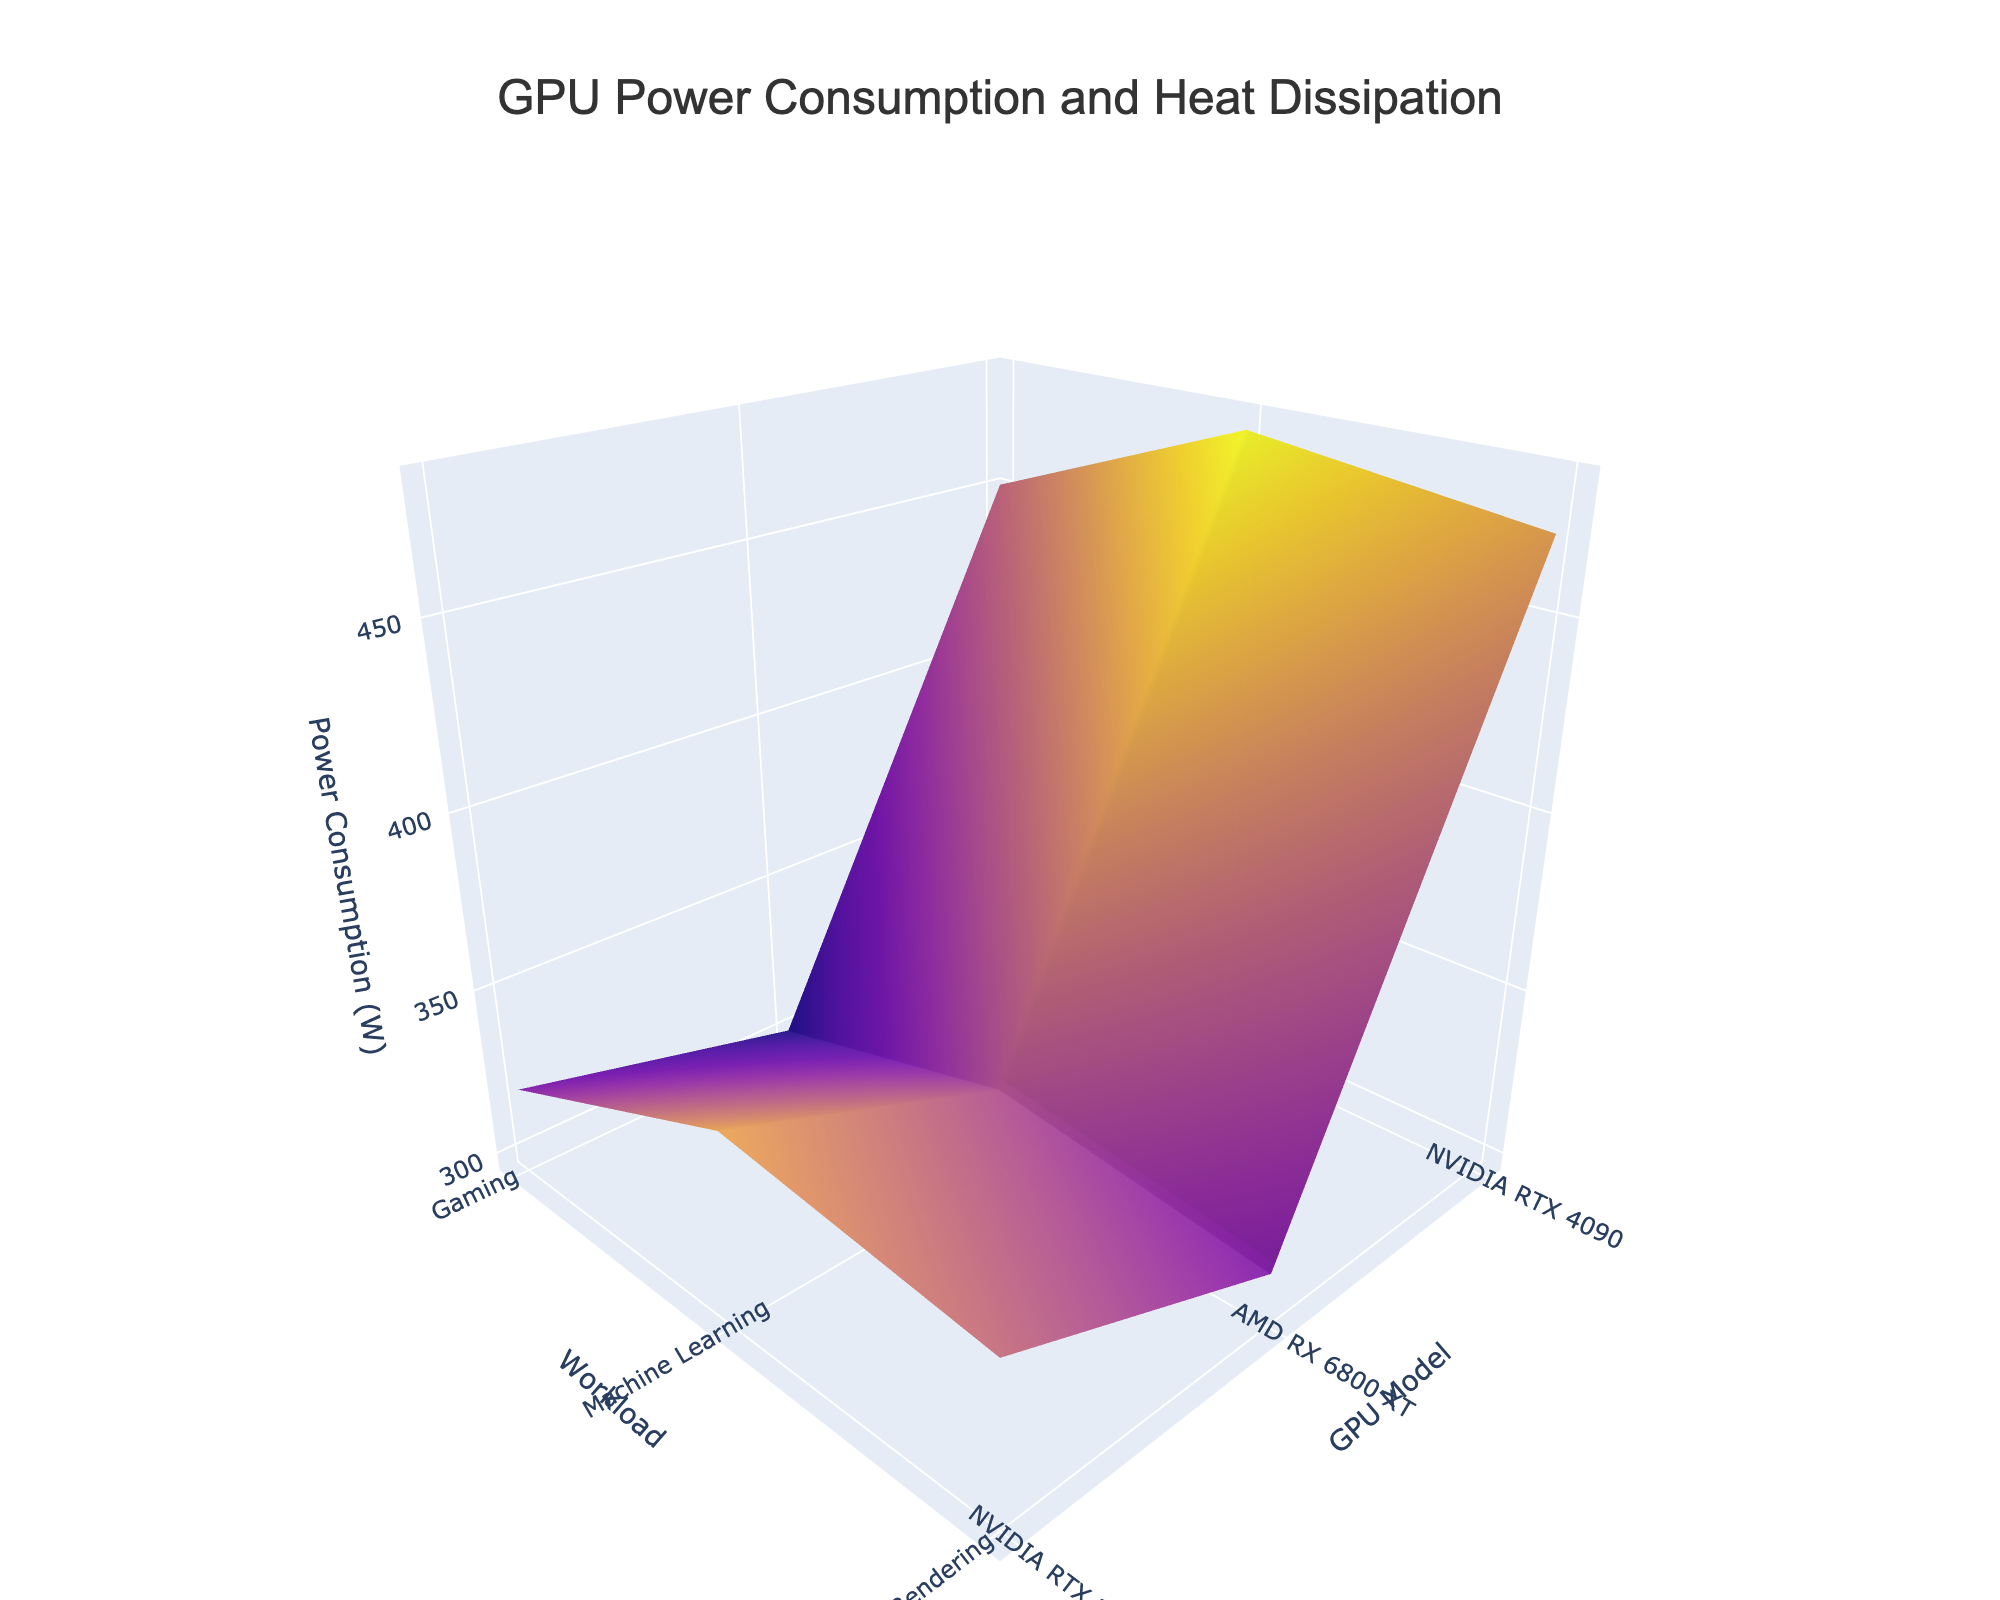What's the title of the plot? The title is written at the top of the plot in the largest and boldest font.
Answer: "GPU Power Consumption and Heat Dissipation" Which GPU model has the highest power consumption for machine learning under air cooling? Look for the point on the surface plot corresponding to machine learning under air cooling. The highest point on the Z-axis (Power Consumption) in that region corresponds to the NVIDIA RTX 4090.
Answer: NVIDIA RTX 4090 How does the heat dissipation of the NVIDIA RTX 3080 compare between air cooling and liquid cooling for gaming workloads? Find the surface sections corresponding to NVIDIA RTX 3080 for gaming with both air cooling and liquid cooling. Compare the heat dissipation values shown by the color, with liquid cooling being cooler, closer to 65°C and air cooling around 75°C.
Answer: Liquid cooling results in lower heat dissipation What is the average power consumption for the AMD RX 6800 XT across all workloads with air cooling? Extract the power consumption data points for the AMD RX 6800 XT with air cooling for all workloads (300W, 320W, 310W). Compute the average: (300 + 320 + 310) / 3.
Answer: 310W Which workload consistently produces the highest heat dissipation for the NVIDIA RTX 3080 irrespective of the cooling solution? Check the color-coded heat dissipation levels for the NVIDIA RTX 3080 under all workloads for both air and liquid cooling. The highest heat dissipation is observed under machine learning for both cooling solutions.
Answer: Machine Learning Compare the power consumption of the NVIDIA RTX 4090 with liquid cooling against the AMD RX 6800 XT with air cooling for rendering workloads. Locate the power consumption values for both conditions: NVIDIA RTX 4090 with liquid cooling is 470W and AMD RX 6800 XT with air cooling is 310W. Compare them.
Answer: NVIDIA RTX 4090 with liquid cooling consumes more power Are there any GPU models for which liquid cooling doesn't significantly affect power consumption? Compare power consumption for each GPU model under both cooling solutions. The NVIDIA RTX 3080 shows the same power consumption values for both cooling types under gaming and rendering workloads.
Answer: NVIDIA RTX 3080 for gaming and rendering What is the median heat dissipation for the NVIDIA RTX 4090 with liquid cooling across all workloads? Find the heat dissipation values for the NVIDIA RTX 4090 with liquid cooling under all workloads (68°C, 73°C, 70°C). The median of these values is 70°C.
Answer: 70°C What's the difference in heat dissipation between the NVIDIA RTX 3080 and AMD RX 6800 XT for machine learning with air cooling? Locate the heat dissipation values for both GPUs for machine learning with air cooling (82°C for NVIDIA RTX 3080 and 78°C for AMD RX 6800 XT). The difference is 82 - 78.
Answer: 4°C Which cooling solution shows a more significant reduction in heat dissipation for the NVIDIA RTX 4080 during rendering when compared to air cooling? Compare heat dissipation values for air (82°C) and liquid cooling (70°C) for the NVIDIA RTX 4090 during rendering. Liquid cooling shows a significant reduction.
Answer: Liquid Cooling 